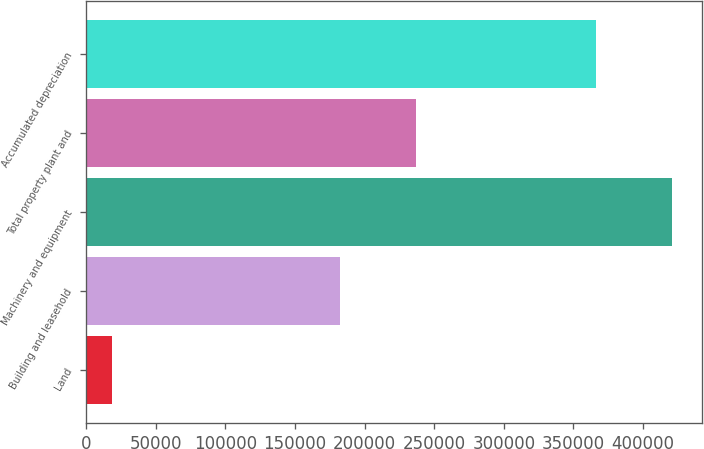Convert chart. <chart><loc_0><loc_0><loc_500><loc_500><bar_chart><fcel>Land<fcel>Building and leasehold<fcel>Machinery and equipment<fcel>Total property plant and<fcel>Accumulated depreciation<nl><fcel>18419<fcel>182014<fcel>421027<fcel>237198<fcel>365843<nl></chart> 